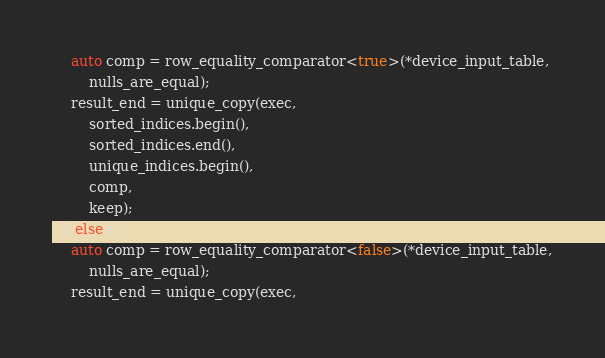<code> <loc_0><loc_0><loc_500><loc_500><_Cuda_>    auto comp = row_equality_comparator<true>(*device_input_table,
        nulls_are_equal);
    result_end = unique_copy(exec,
        sorted_indices.begin(),
        sorted_indices.end(),
        unique_indices.begin(),
        comp,
        keep);
  } else {
    auto comp = row_equality_comparator<false>(*device_input_table,
        nulls_are_equal);
    result_end = unique_copy(exec,</code> 